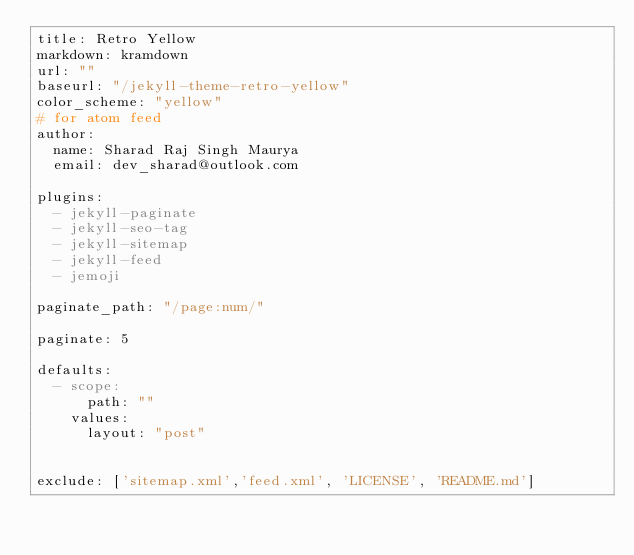<code> <loc_0><loc_0><loc_500><loc_500><_YAML_>title: Retro Yellow
markdown: kramdown
url: ""
baseurl: "/jekyll-theme-retro-yellow"
color_scheme: "yellow"
# for atom feed
author:
  name: Sharad Raj Singh Maurya
  email: dev_sharad@outlook.com

plugins:
  - jekyll-paginate
  - jekyll-seo-tag
  - jekyll-sitemap
  - jekyll-feed
  - jemoji

paginate_path: "/page:num/"

paginate: 5

defaults:
  - scope:
      path: ""
    values:
      layout: "post"


exclude: ['sitemap.xml','feed.xml', 'LICENSE', 'README.md']</code> 